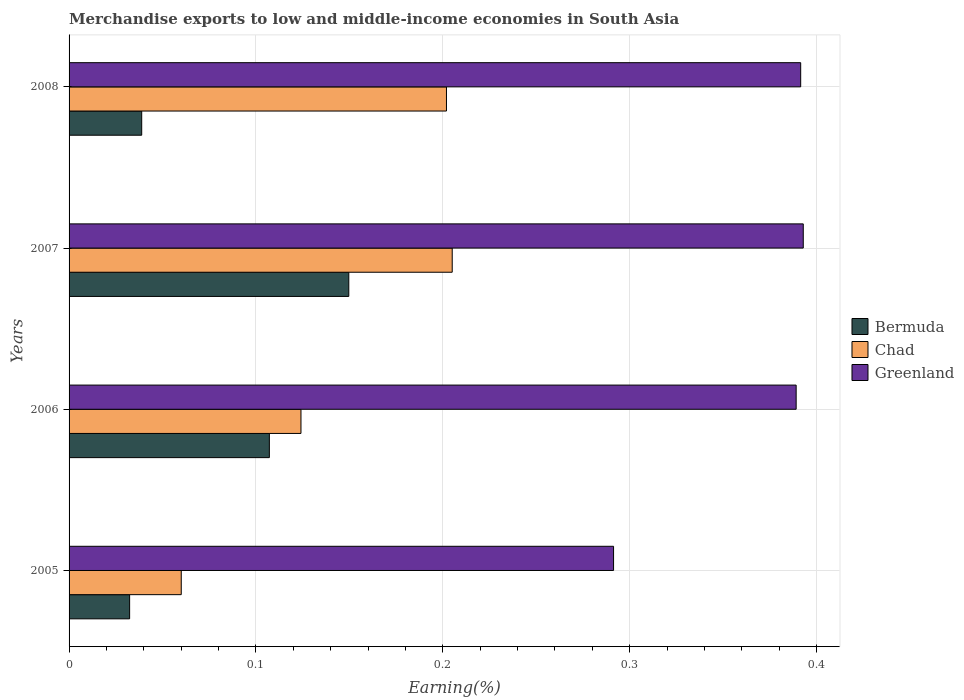How many different coloured bars are there?
Provide a short and direct response. 3. How many groups of bars are there?
Offer a very short reply. 4. Are the number of bars per tick equal to the number of legend labels?
Keep it short and to the point. Yes. Are the number of bars on each tick of the Y-axis equal?
Provide a short and direct response. Yes. How many bars are there on the 2nd tick from the top?
Offer a very short reply. 3. What is the label of the 2nd group of bars from the top?
Keep it short and to the point. 2007. In how many cases, is the number of bars for a given year not equal to the number of legend labels?
Give a very brief answer. 0. What is the percentage of amount earned from merchandise exports in Chad in 2005?
Provide a short and direct response. 0.06. Across all years, what is the maximum percentage of amount earned from merchandise exports in Bermuda?
Give a very brief answer. 0.15. Across all years, what is the minimum percentage of amount earned from merchandise exports in Bermuda?
Offer a terse response. 0.03. In which year was the percentage of amount earned from merchandise exports in Bermuda maximum?
Keep it short and to the point. 2007. What is the total percentage of amount earned from merchandise exports in Greenland in the graph?
Make the answer very short. 1.46. What is the difference between the percentage of amount earned from merchandise exports in Chad in 2005 and that in 2006?
Offer a terse response. -0.06. What is the difference between the percentage of amount earned from merchandise exports in Chad in 2008 and the percentage of amount earned from merchandise exports in Bermuda in 2007?
Make the answer very short. 0.05. What is the average percentage of amount earned from merchandise exports in Greenland per year?
Ensure brevity in your answer.  0.37. In the year 2006, what is the difference between the percentage of amount earned from merchandise exports in Greenland and percentage of amount earned from merchandise exports in Chad?
Your response must be concise. 0.26. What is the ratio of the percentage of amount earned from merchandise exports in Bermuda in 2006 to that in 2007?
Your response must be concise. 0.72. Is the percentage of amount earned from merchandise exports in Greenland in 2006 less than that in 2007?
Your response must be concise. Yes. What is the difference between the highest and the second highest percentage of amount earned from merchandise exports in Bermuda?
Your response must be concise. 0.04. What is the difference between the highest and the lowest percentage of amount earned from merchandise exports in Bermuda?
Offer a very short reply. 0.12. In how many years, is the percentage of amount earned from merchandise exports in Greenland greater than the average percentage of amount earned from merchandise exports in Greenland taken over all years?
Your response must be concise. 3. Is the sum of the percentage of amount earned from merchandise exports in Bermuda in 2005 and 2008 greater than the maximum percentage of amount earned from merchandise exports in Chad across all years?
Keep it short and to the point. No. What does the 3rd bar from the top in 2006 represents?
Your answer should be compact. Bermuda. What does the 2nd bar from the bottom in 2006 represents?
Your answer should be very brief. Chad. How many bars are there?
Provide a short and direct response. 12. What is the difference between two consecutive major ticks on the X-axis?
Keep it short and to the point. 0.1. Are the values on the major ticks of X-axis written in scientific E-notation?
Give a very brief answer. No. What is the title of the graph?
Provide a short and direct response. Merchandise exports to low and middle-income economies in South Asia. What is the label or title of the X-axis?
Your answer should be very brief. Earning(%). What is the label or title of the Y-axis?
Offer a very short reply. Years. What is the Earning(%) of Bermuda in 2005?
Your response must be concise. 0.03. What is the Earning(%) in Chad in 2005?
Provide a succinct answer. 0.06. What is the Earning(%) of Greenland in 2005?
Ensure brevity in your answer.  0.29. What is the Earning(%) in Bermuda in 2006?
Give a very brief answer. 0.11. What is the Earning(%) in Chad in 2006?
Make the answer very short. 0.12. What is the Earning(%) in Greenland in 2006?
Provide a short and direct response. 0.39. What is the Earning(%) in Bermuda in 2007?
Offer a terse response. 0.15. What is the Earning(%) in Chad in 2007?
Ensure brevity in your answer.  0.21. What is the Earning(%) in Greenland in 2007?
Your response must be concise. 0.39. What is the Earning(%) in Bermuda in 2008?
Provide a short and direct response. 0.04. What is the Earning(%) in Chad in 2008?
Provide a succinct answer. 0.2. What is the Earning(%) in Greenland in 2008?
Your answer should be compact. 0.39. Across all years, what is the maximum Earning(%) of Bermuda?
Give a very brief answer. 0.15. Across all years, what is the maximum Earning(%) of Chad?
Provide a succinct answer. 0.21. Across all years, what is the maximum Earning(%) in Greenland?
Ensure brevity in your answer.  0.39. Across all years, what is the minimum Earning(%) in Bermuda?
Provide a short and direct response. 0.03. Across all years, what is the minimum Earning(%) of Chad?
Your answer should be compact. 0.06. Across all years, what is the minimum Earning(%) in Greenland?
Provide a short and direct response. 0.29. What is the total Earning(%) in Bermuda in the graph?
Provide a short and direct response. 0.33. What is the total Earning(%) in Chad in the graph?
Ensure brevity in your answer.  0.59. What is the total Earning(%) of Greenland in the graph?
Your answer should be compact. 1.46. What is the difference between the Earning(%) of Bermuda in 2005 and that in 2006?
Offer a terse response. -0.07. What is the difference between the Earning(%) in Chad in 2005 and that in 2006?
Provide a succinct answer. -0.06. What is the difference between the Earning(%) in Greenland in 2005 and that in 2006?
Provide a succinct answer. -0.1. What is the difference between the Earning(%) of Bermuda in 2005 and that in 2007?
Your answer should be very brief. -0.12. What is the difference between the Earning(%) of Chad in 2005 and that in 2007?
Your answer should be very brief. -0.14. What is the difference between the Earning(%) in Greenland in 2005 and that in 2007?
Provide a short and direct response. -0.1. What is the difference between the Earning(%) in Bermuda in 2005 and that in 2008?
Give a very brief answer. -0.01. What is the difference between the Earning(%) in Chad in 2005 and that in 2008?
Provide a succinct answer. -0.14. What is the difference between the Earning(%) of Greenland in 2005 and that in 2008?
Your answer should be compact. -0.1. What is the difference between the Earning(%) in Bermuda in 2006 and that in 2007?
Provide a succinct answer. -0.04. What is the difference between the Earning(%) of Chad in 2006 and that in 2007?
Keep it short and to the point. -0.08. What is the difference between the Earning(%) of Greenland in 2006 and that in 2007?
Make the answer very short. -0. What is the difference between the Earning(%) of Bermuda in 2006 and that in 2008?
Ensure brevity in your answer.  0.07. What is the difference between the Earning(%) in Chad in 2006 and that in 2008?
Your response must be concise. -0.08. What is the difference between the Earning(%) of Greenland in 2006 and that in 2008?
Your answer should be compact. -0. What is the difference between the Earning(%) of Bermuda in 2007 and that in 2008?
Your answer should be compact. 0.11. What is the difference between the Earning(%) of Chad in 2007 and that in 2008?
Ensure brevity in your answer.  0. What is the difference between the Earning(%) of Greenland in 2007 and that in 2008?
Your answer should be compact. 0. What is the difference between the Earning(%) of Bermuda in 2005 and the Earning(%) of Chad in 2006?
Provide a short and direct response. -0.09. What is the difference between the Earning(%) of Bermuda in 2005 and the Earning(%) of Greenland in 2006?
Provide a succinct answer. -0.36. What is the difference between the Earning(%) of Chad in 2005 and the Earning(%) of Greenland in 2006?
Your answer should be compact. -0.33. What is the difference between the Earning(%) of Bermuda in 2005 and the Earning(%) of Chad in 2007?
Make the answer very short. -0.17. What is the difference between the Earning(%) in Bermuda in 2005 and the Earning(%) in Greenland in 2007?
Provide a short and direct response. -0.36. What is the difference between the Earning(%) of Chad in 2005 and the Earning(%) of Greenland in 2007?
Provide a succinct answer. -0.33. What is the difference between the Earning(%) of Bermuda in 2005 and the Earning(%) of Chad in 2008?
Keep it short and to the point. -0.17. What is the difference between the Earning(%) of Bermuda in 2005 and the Earning(%) of Greenland in 2008?
Provide a succinct answer. -0.36. What is the difference between the Earning(%) in Chad in 2005 and the Earning(%) in Greenland in 2008?
Provide a short and direct response. -0.33. What is the difference between the Earning(%) in Bermuda in 2006 and the Earning(%) in Chad in 2007?
Ensure brevity in your answer.  -0.1. What is the difference between the Earning(%) in Bermuda in 2006 and the Earning(%) in Greenland in 2007?
Your response must be concise. -0.29. What is the difference between the Earning(%) in Chad in 2006 and the Earning(%) in Greenland in 2007?
Keep it short and to the point. -0.27. What is the difference between the Earning(%) of Bermuda in 2006 and the Earning(%) of Chad in 2008?
Your response must be concise. -0.09. What is the difference between the Earning(%) in Bermuda in 2006 and the Earning(%) in Greenland in 2008?
Provide a short and direct response. -0.28. What is the difference between the Earning(%) in Chad in 2006 and the Earning(%) in Greenland in 2008?
Your response must be concise. -0.27. What is the difference between the Earning(%) of Bermuda in 2007 and the Earning(%) of Chad in 2008?
Make the answer very short. -0.05. What is the difference between the Earning(%) of Bermuda in 2007 and the Earning(%) of Greenland in 2008?
Provide a short and direct response. -0.24. What is the difference between the Earning(%) of Chad in 2007 and the Earning(%) of Greenland in 2008?
Make the answer very short. -0.19. What is the average Earning(%) of Bermuda per year?
Make the answer very short. 0.08. What is the average Earning(%) of Chad per year?
Make the answer very short. 0.15. What is the average Earning(%) of Greenland per year?
Offer a very short reply. 0.37. In the year 2005, what is the difference between the Earning(%) of Bermuda and Earning(%) of Chad?
Your answer should be very brief. -0.03. In the year 2005, what is the difference between the Earning(%) in Bermuda and Earning(%) in Greenland?
Your answer should be very brief. -0.26. In the year 2005, what is the difference between the Earning(%) in Chad and Earning(%) in Greenland?
Your response must be concise. -0.23. In the year 2006, what is the difference between the Earning(%) of Bermuda and Earning(%) of Chad?
Keep it short and to the point. -0.02. In the year 2006, what is the difference between the Earning(%) of Bermuda and Earning(%) of Greenland?
Keep it short and to the point. -0.28. In the year 2006, what is the difference between the Earning(%) in Chad and Earning(%) in Greenland?
Offer a very short reply. -0.27. In the year 2007, what is the difference between the Earning(%) of Bermuda and Earning(%) of Chad?
Provide a short and direct response. -0.06. In the year 2007, what is the difference between the Earning(%) of Bermuda and Earning(%) of Greenland?
Provide a succinct answer. -0.24. In the year 2007, what is the difference between the Earning(%) of Chad and Earning(%) of Greenland?
Ensure brevity in your answer.  -0.19. In the year 2008, what is the difference between the Earning(%) of Bermuda and Earning(%) of Chad?
Make the answer very short. -0.16. In the year 2008, what is the difference between the Earning(%) in Bermuda and Earning(%) in Greenland?
Offer a very short reply. -0.35. In the year 2008, what is the difference between the Earning(%) in Chad and Earning(%) in Greenland?
Keep it short and to the point. -0.19. What is the ratio of the Earning(%) of Bermuda in 2005 to that in 2006?
Ensure brevity in your answer.  0.3. What is the ratio of the Earning(%) of Chad in 2005 to that in 2006?
Your answer should be compact. 0.48. What is the ratio of the Earning(%) of Greenland in 2005 to that in 2006?
Provide a succinct answer. 0.75. What is the ratio of the Earning(%) in Bermuda in 2005 to that in 2007?
Provide a short and direct response. 0.22. What is the ratio of the Earning(%) of Chad in 2005 to that in 2007?
Your response must be concise. 0.29. What is the ratio of the Earning(%) in Greenland in 2005 to that in 2007?
Make the answer very short. 0.74. What is the ratio of the Earning(%) of Bermuda in 2005 to that in 2008?
Give a very brief answer. 0.83. What is the ratio of the Earning(%) of Chad in 2005 to that in 2008?
Keep it short and to the point. 0.3. What is the ratio of the Earning(%) in Greenland in 2005 to that in 2008?
Give a very brief answer. 0.74. What is the ratio of the Earning(%) of Bermuda in 2006 to that in 2007?
Your answer should be very brief. 0.72. What is the ratio of the Earning(%) in Chad in 2006 to that in 2007?
Your answer should be very brief. 0.61. What is the ratio of the Earning(%) of Greenland in 2006 to that in 2007?
Your answer should be very brief. 0.99. What is the ratio of the Earning(%) of Bermuda in 2006 to that in 2008?
Give a very brief answer. 2.76. What is the ratio of the Earning(%) of Chad in 2006 to that in 2008?
Give a very brief answer. 0.61. What is the ratio of the Earning(%) in Bermuda in 2007 to that in 2008?
Give a very brief answer. 3.85. What is the ratio of the Earning(%) of Chad in 2007 to that in 2008?
Ensure brevity in your answer.  1.02. What is the ratio of the Earning(%) of Greenland in 2007 to that in 2008?
Ensure brevity in your answer.  1. What is the difference between the highest and the second highest Earning(%) of Bermuda?
Your answer should be very brief. 0.04. What is the difference between the highest and the second highest Earning(%) of Chad?
Make the answer very short. 0. What is the difference between the highest and the second highest Earning(%) of Greenland?
Your response must be concise. 0. What is the difference between the highest and the lowest Earning(%) in Bermuda?
Your response must be concise. 0.12. What is the difference between the highest and the lowest Earning(%) in Chad?
Provide a short and direct response. 0.14. What is the difference between the highest and the lowest Earning(%) in Greenland?
Ensure brevity in your answer.  0.1. 